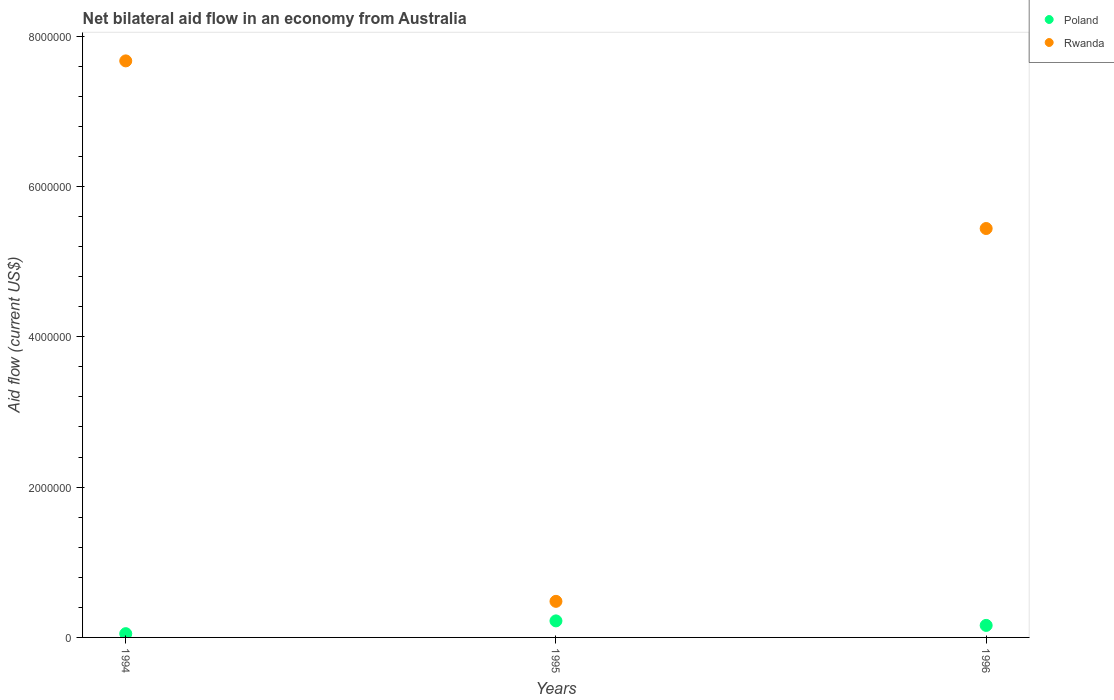How many different coloured dotlines are there?
Provide a succinct answer. 2. Is the number of dotlines equal to the number of legend labels?
Keep it short and to the point. Yes. What is the net bilateral aid flow in Poland in 1994?
Ensure brevity in your answer.  5.00e+04. In which year was the net bilateral aid flow in Poland minimum?
Ensure brevity in your answer.  1994. What is the total net bilateral aid flow in Rwanda in the graph?
Your answer should be very brief. 1.36e+07. What is the difference between the net bilateral aid flow in Rwanda in 1994 and that in 1996?
Offer a terse response. 2.23e+06. What is the difference between the net bilateral aid flow in Rwanda in 1994 and the net bilateral aid flow in Poland in 1996?
Give a very brief answer. 7.51e+06. What is the average net bilateral aid flow in Rwanda per year?
Make the answer very short. 4.53e+06. In the year 1996, what is the difference between the net bilateral aid flow in Poland and net bilateral aid flow in Rwanda?
Your answer should be compact. -5.28e+06. In how many years, is the net bilateral aid flow in Rwanda greater than 4000000 US$?
Provide a short and direct response. 2. What is the ratio of the net bilateral aid flow in Rwanda in 1995 to that in 1996?
Your response must be concise. 0.09. Is the difference between the net bilateral aid flow in Poland in 1994 and 1996 greater than the difference between the net bilateral aid flow in Rwanda in 1994 and 1996?
Ensure brevity in your answer.  No. What is the difference between the highest and the lowest net bilateral aid flow in Rwanda?
Your response must be concise. 7.19e+06. Is the sum of the net bilateral aid flow in Poland in 1994 and 1995 greater than the maximum net bilateral aid flow in Rwanda across all years?
Keep it short and to the point. No. Is the net bilateral aid flow in Poland strictly greater than the net bilateral aid flow in Rwanda over the years?
Your answer should be very brief. No. How many years are there in the graph?
Offer a very short reply. 3. Are the values on the major ticks of Y-axis written in scientific E-notation?
Provide a short and direct response. No. What is the title of the graph?
Your response must be concise. Net bilateral aid flow in an economy from Australia. Does "Rwanda" appear as one of the legend labels in the graph?
Offer a terse response. Yes. What is the label or title of the Y-axis?
Offer a terse response. Aid flow (current US$). What is the Aid flow (current US$) of Rwanda in 1994?
Your answer should be compact. 7.67e+06. What is the Aid flow (current US$) of Poland in 1995?
Your answer should be compact. 2.20e+05. What is the Aid flow (current US$) in Poland in 1996?
Provide a short and direct response. 1.60e+05. What is the Aid flow (current US$) in Rwanda in 1996?
Provide a short and direct response. 5.44e+06. Across all years, what is the maximum Aid flow (current US$) in Rwanda?
Provide a short and direct response. 7.67e+06. Across all years, what is the minimum Aid flow (current US$) in Rwanda?
Ensure brevity in your answer.  4.80e+05. What is the total Aid flow (current US$) in Rwanda in the graph?
Offer a terse response. 1.36e+07. What is the difference between the Aid flow (current US$) in Rwanda in 1994 and that in 1995?
Provide a succinct answer. 7.19e+06. What is the difference between the Aid flow (current US$) of Poland in 1994 and that in 1996?
Offer a terse response. -1.10e+05. What is the difference between the Aid flow (current US$) of Rwanda in 1994 and that in 1996?
Offer a terse response. 2.23e+06. What is the difference between the Aid flow (current US$) of Rwanda in 1995 and that in 1996?
Offer a terse response. -4.96e+06. What is the difference between the Aid flow (current US$) in Poland in 1994 and the Aid flow (current US$) in Rwanda in 1995?
Provide a succinct answer. -4.30e+05. What is the difference between the Aid flow (current US$) of Poland in 1994 and the Aid flow (current US$) of Rwanda in 1996?
Provide a succinct answer. -5.39e+06. What is the difference between the Aid flow (current US$) in Poland in 1995 and the Aid flow (current US$) in Rwanda in 1996?
Ensure brevity in your answer.  -5.22e+06. What is the average Aid flow (current US$) of Poland per year?
Provide a short and direct response. 1.43e+05. What is the average Aid flow (current US$) of Rwanda per year?
Keep it short and to the point. 4.53e+06. In the year 1994, what is the difference between the Aid flow (current US$) in Poland and Aid flow (current US$) in Rwanda?
Provide a short and direct response. -7.62e+06. In the year 1996, what is the difference between the Aid flow (current US$) of Poland and Aid flow (current US$) of Rwanda?
Your response must be concise. -5.28e+06. What is the ratio of the Aid flow (current US$) of Poland in 1994 to that in 1995?
Your response must be concise. 0.23. What is the ratio of the Aid flow (current US$) in Rwanda in 1994 to that in 1995?
Keep it short and to the point. 15.98. What is the ratio of the Aid flow (current US$) of Poland in 1994 to that in 1996?
Offer a very short reply. 0.31. What is the ratio of the Aid flow (current US$) in Rwanda in 1994 to that in 1996?
Offer a terse response. 1.41. What is the ratio of the Aid flow (current US$) in Poland in 1995 to that in 1996?
Keep it short and to the point. 1.38. What is the ratio of the Aid flow (current US$) in Rwanda in 1995 to that in 1996?
Ensure brevity in your answer.  0.09. What is the difference between the highest and the second highest Aid flow (current US$) of Rwanda?
Keep it short and to the point. 2.23e+06. What is the difference between the highest and the lowest Aid flow (current US$) of Poland?
Provide a succinct answer. 1.70e+05. What is the difference between the highest and the lowest Aid flow (current US$) in Rwanda?
Make the answer very short. 7.19e+06. 